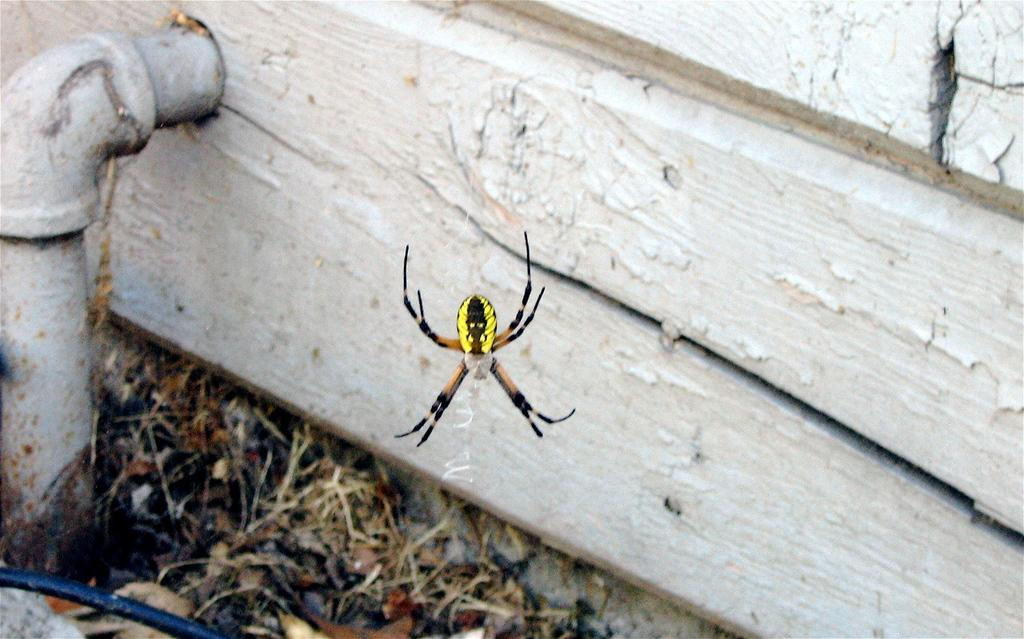What is the main subject in the middle of the image? There is a spider in the middle of the image. What type of vegetation can be seen at the bottom of the image? There are leaves at the bottom of the image. What structure is located on the left side of the image? There is a pipe on the left side of the image. What material is present on the right side of the image? There is wood on the right side of the image. What type of offer is being made by the geese in the image? There are no geese present in the image, so no offer can be made by them. 